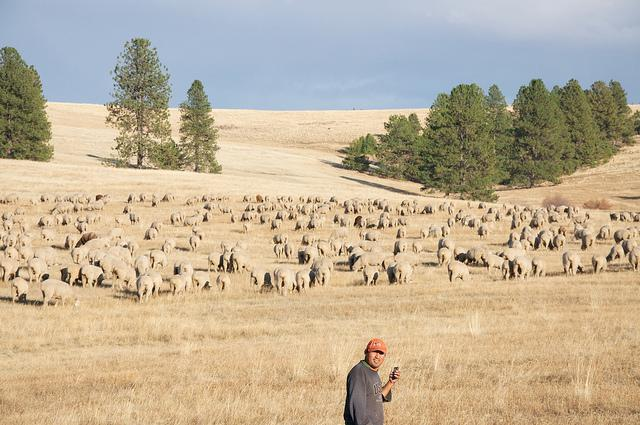Why is he standing far from the animals?

Choices:
A) avoid spooking
B) dangerous animals
C) he's afraid
D) private property avoid spooking 